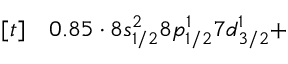<formula> <loc_0><loc_0><loc_500><loc_500>\begin{array} { r l } { [ t ] } & 0 . 8 5 \cdot 8 s _ { 1 / 2 } ^ { 2 } 8 p _ { 1 / 2 } ^ { 1 } 7 d _ { 3 / 2 } ^ { 1 } + } \end{array}</formula> 